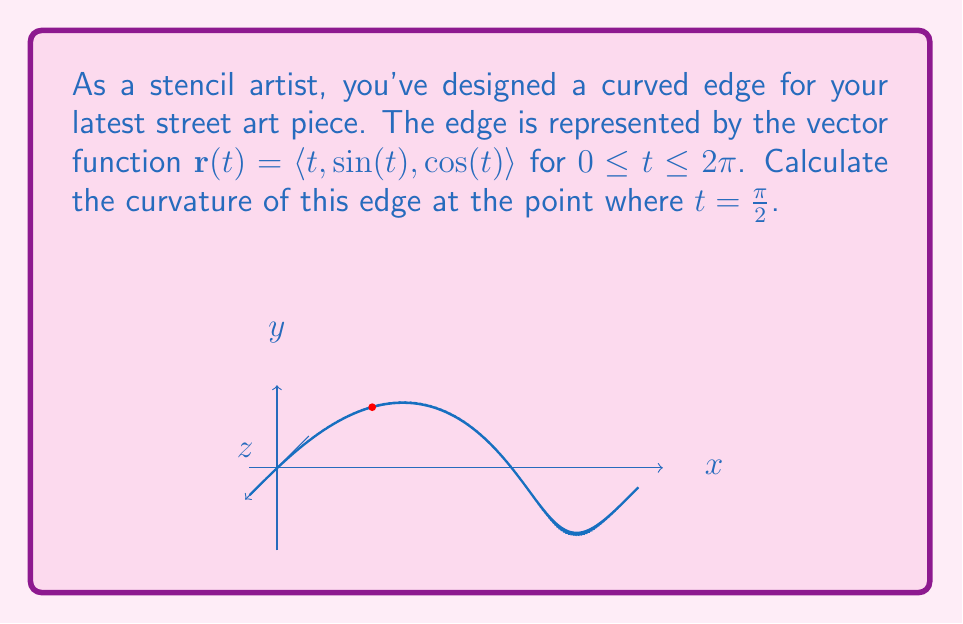Could you help me with this problem? To calculate the curvature, we'll use the formula:

$$\kappa = \frac{|\mathbf{r}'(t) \times \mathbf{r}''(t)|}{|\mathbf{r}'(t)|^3}$$

Step 1: Calculate $\mathbf{r}'(t)$
$$\mathbf{r}'(t) = \langle 1, \cos(t), -\sin(t) \rangle$$

Step 2: Calculate $\mathbf{r}''(t)$
$$\mathbf{r}''(t) = \langle 0, -\sin(t), -\cos(t) \rangle$$

Step 3: Evaluate $\mathbf{r}'(\frac{\pi}{2})$ and $\mathbf{r}''(\frac{\pi}{2})$
$$\mathbf{r}'(\frac{\pi}{2}) = \langle 1, 0, -1 \rangle$$
$$\mathbf{r}''(\frac{\pi}{2}) = \langle 0, -1, 0 \rangle$$

Step 4: Calculate $\mathbf{r}'(\frac{\pi}{2}) \times \mathbf{r}''(\frac{\pi}{2})$
$$\mathbf{r}'(\frac{\pi}{2}) \times \mathbf{r}''(\frac{\pi}{2}) = \langle 1, 0, 1 \rangle$$

Step 5: Calculate $|\mathbf{r}'(\frac{\pi}{2}) \times \mathbf{r}''(\frac{\pi}{2})|$
$$|\mathbf{r}'(\frac{\pi}{2}) \times \mathbf{r}''(\frac{\pi}{2})| = \sqrt{1^2 + 0^2 + 1^2} = \sqrt{2}$$

Step 6: Calculate $|\mathbf{r}'(\frac{\pi}{2})|^3$
$$|\mathbf{r}'(\frac{\pi}{2})|^3 = (\sqrt{1^2 + 0^2 + (-1)^2})^3 = (\sqrt{2})^3 = 2\sqrt{2}$$

Step 7: Apply the curvature formula
$$\kappa = \frac{|\mathbf{r}'(\frac{\pi}{2}) \times \mathbf{r}''(\frac{\pi}{2})|}{|\mathbf{r}'(\frac{\pi}{2})|^3} = \frac{\sqrt{2}}{2\sqrt{2}} = \frac{1}{2}$$
Answer: $\frac{1}{2}$ 